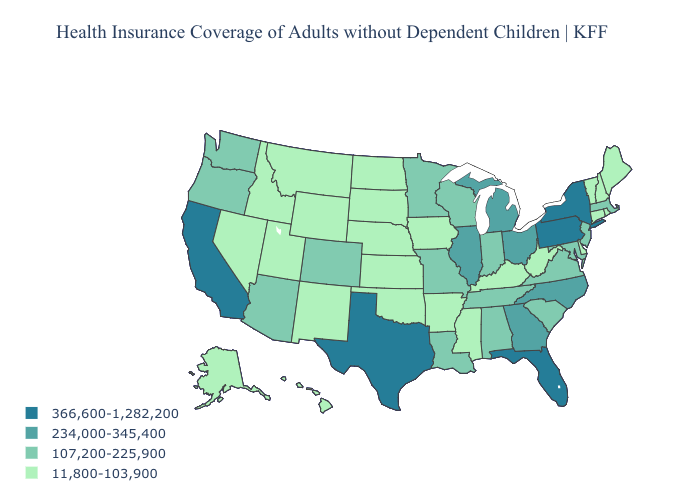Does the first symbol in the legend represent the smallest category?
Keep it brief. No. Among the states that border Mississippi , which have the lowest value?
Give a very brief answer. Arkansas. Among the states that border Iowa , does Nebraska have the highest value?
Give a very brief answer. No. What is the highest value in the USA?
Write a very short answer. 366,600-1,282,200. What is the highest value in the USA?
Answer briefly. 366,600-1,282,200. Does Ohio have the highest value in the MidWest?
Concise answer only. Yes. Name the states that have a value in the range 107,200-225,900?
Write a very short answer. Alabama, Arizona, Colorado, Indiana, Louisiana, Maryland, Massachusetts, Minnesota, Missouri, New Jersey, Oregon, South Carolina, Tennessee, Virginia, Washington, Wisconsin. Name the states that have a value in the range 107,200-225,900?
Be succinct. Alabama, Arizona, Colorado, Indiana, Louisiana, Maryland, Massachusetts, Minnesota, Missouri, New Jersey, Oregon, South Carolina, Tennessee, Virginia, Washington, Wisconsin. Name the states that have a value in the range 366,600-1,282,200?
Be succinct. California, Florida, New York, Pennsylvania, Texas. Which states have the highest value in the USA?
Keep it brief. California, Florida, New York, Pennsylvania, Texas. Name the states that have a value in the range 234,000-345,400?
Concise answer only. Georgia, Illinois, Michigan, North Carolina, Ohio. Does Texas have the highest value in the South?
Write a very short answer. Yes. What is the value of Vermont?
Concise answer only. 11,800-103,900. What is the value of Kentucky?
Be succinct. 11,800-103,900. 